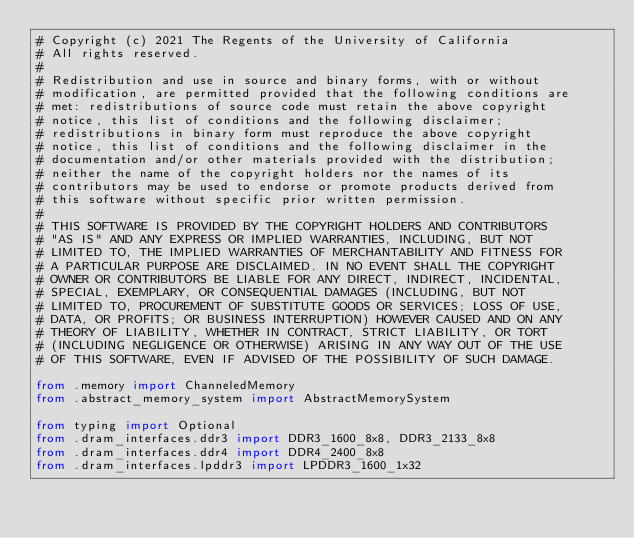Convert code to text. <code><loc_0><loc_0><loc_500><loc_500><_Python_># Copyright (c) 2021 The Regents of the University of California
# All rights reserved.
#
# Redistribution and use in source and binary forms, with or without
# modification, are permitted provided that the following conditions are
# met: redistributions of source code must retain the above copyright
# notice, this list of conditions and the following disclaimer;
# redistributions in binary form must reproduce the above copyright
# notice, this list of conditions and the following disclaimer in the
# documentation and/or other materials provided with the distribution;
# neither the name of the copyright holders nor the names of its
# contributors may be used to endorse or promote products derived from
# this software without specific prior written permission.
#
# THIS SOFTWARE IS PROVIDED BY THE COPYRIGHT HOLDERS AND CONTRIBUTORS
# "AS IS" AND ANY EXPRESS OR IMPLIED WARRANTIES, INCLUDING, BUT NOT
# LIMITED TO, THE IMPLIED WARRANTIES OF MERCHANTABILITY AND FITNESS FOR
# A PARTICULAR PURPOSE ARE DISCLAIMED. IN NO EVENT SHALL THE COPYRIGHT
# OWNER OR CONTRIBUTORS BE LIABLE FOR ANY DIRECT, INDIRECT, INCIDENTAL,
# SPECIAL, EXEMPLARY, OR CONSEQUENTIAL DAMAGES (INCLUDING, BUT NOT
# LIMITED TO, PROCUREMENT OF SUBSTITUTE GOODS OR SERVICES; LOSS OF USE,
# DATA, OR PROFITS; OR BUSINESS INTERRUPTION) HOWEVER CAUSED AND ON ANY
# THEORY OF LIABILITY, WHETHER IN CONTRACT, STRICT LIABILITY, OR TORT
# (INCLUDING NEGLIGENCE OR OTHERWISE) ARISING IN ANY WAY OUT OF THE USE
# OF THIS SOFTWARE, EVEN IF ADVISED OF THE POSSIBILITY OF SUCH DAMAGE.

from .memory import ChanneledMemory
from .abstract_memory_system import AbstractMemorySystem

from typing import Optional
from .dram_interfaces.ddr3 import DDR3_1600_8x8, DDR3_2133_8x8
from .dram_interfaces.ddr4 import DDR4_2400_8x8
from .dram_interfaces.lpddr3 import LPDDR3_1600_1x32</code> 